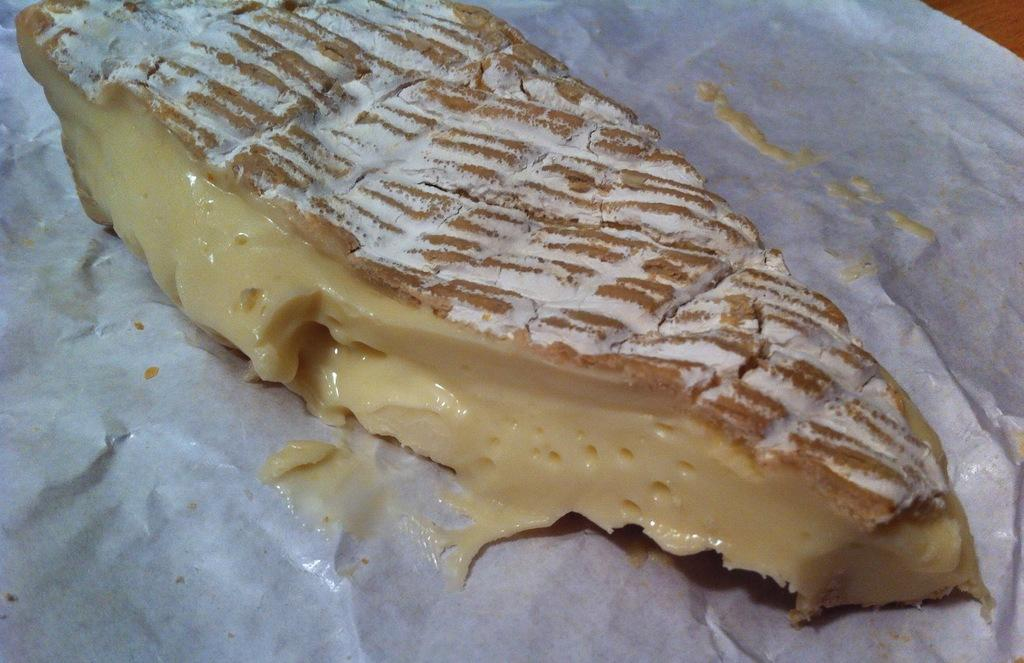What is placed on the table in the image? There is an eatable item placed on a table in the image. What type of branch can be seen growing from the clock in the image? There is no branch or clock present in the image; it only features an eatable item placed on a table. 